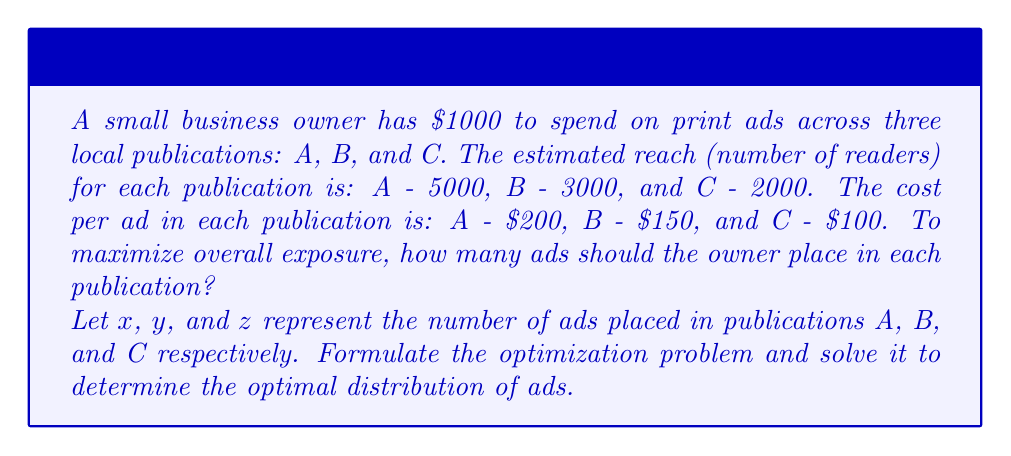Teach me how to tackle this problem. To solve this optimization problem, we'll follow these steps:

1. Define the objective function:
   We want to maximize the total reach, which is given by:
   $$f(x,y,z) = 5000x + 3000y + 2000z$$

2. Define the constraints:
   a) Budget constraint: The total cost must not exceed $1000
   $$200x + 150y + 100z \leq 1000$$
   b) Non-negativity constraints: The number of ads must be non-negative
   $$x \geq 0, y \geq 0, z \geq 0$$

3. Use the method of Lagrange multipliers:
   Form the Lagrangian:
   $$L(x,y,z,\lambda) = 5000x + 3000y + 2000z - \lambda(200x + 150y + 100z - 1000)$$

4. Find the partial derivatives and set them to zero:
   $$\frac{\partial L}{\partial x} = 5000 - 200\lambda = 0$$
   $$\frac{\partial L}{\partial y} = 3000 - 150\lambda = 0$$
   $$\frac{\partial L}{\partial z} = 2000 - 100\lambda = 0$$
   $$\frac{\partial L}{\partial \lambda} = 200x + 150y + 100z - 1000 = 0$$

5. Solve the system of equations:
   From the first three equations:
   $$\lambda = 25 = 20 = 20$$
   This implies that $x = 0$ (since 25 ≠ 20)

   Substituting $\lambda = 20$ into the second and third equations:
   $$3000 = 150 \cdot 20 \implies y = 4$$
   $$2000 = 100 \cdot 20 \implies z = 4$$

   Verify the budget constraint:
   $$200(0) + 150(4) + 100(4) = 1000$$

Therefore, the optimal distribution is to place 0 ads in publication A, 4 ads in publication B, and 4 ads in publication C.
Answer: A: 0 ads, B: 4 ads, C: 4 ads 